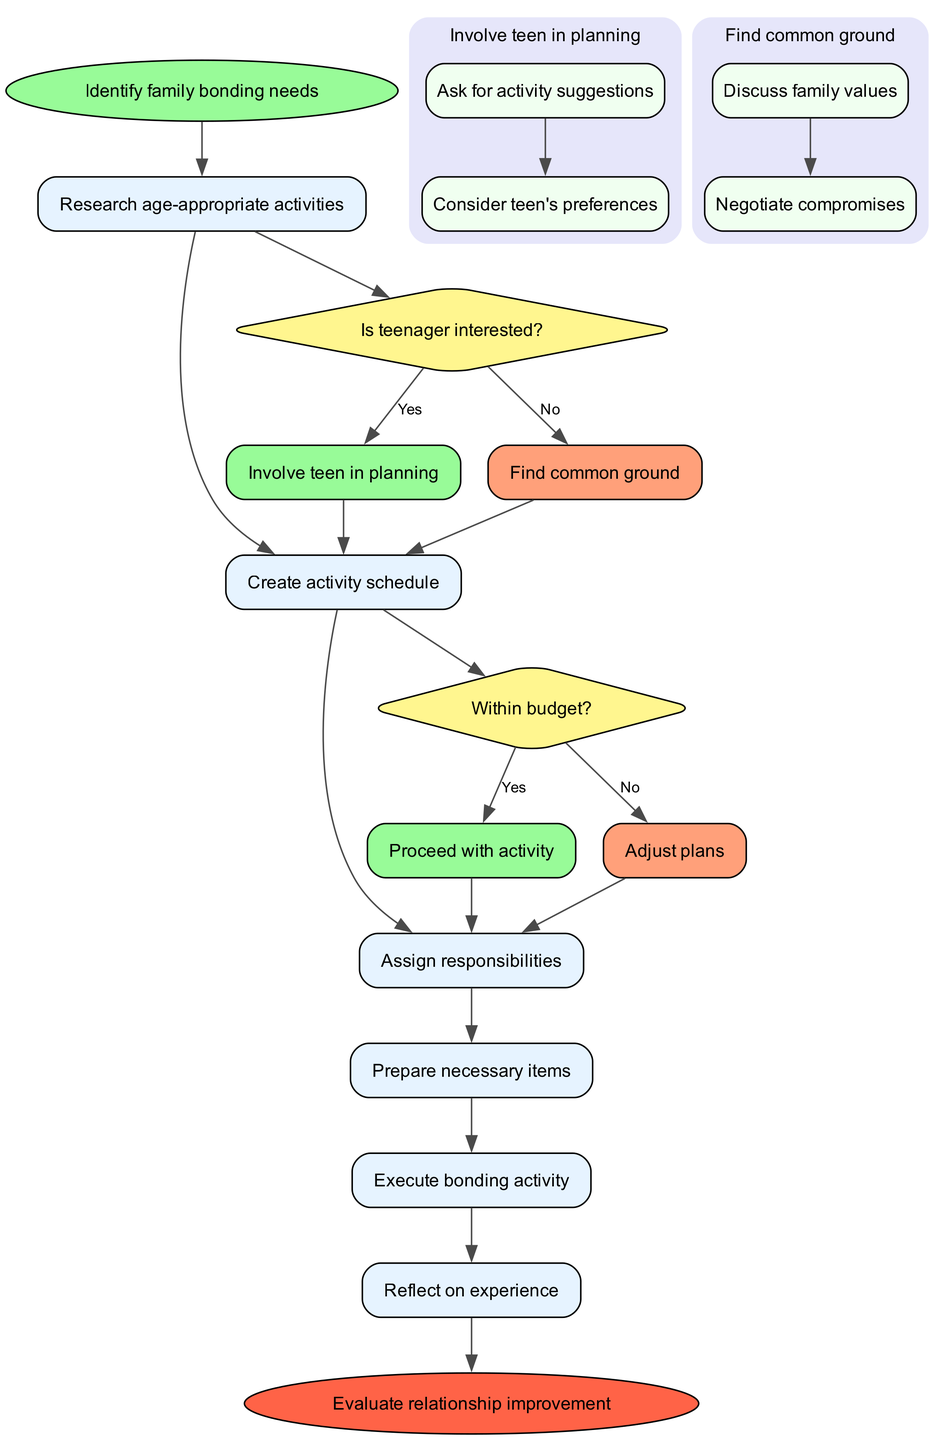What is the starting point of the workflow? The starting point is clearly labeled as "Identify family bonding needs," which is the first node in the diagram.
Answer: Identify family bonding needs How many decision points are in the diagram? There are two decision points: "Is teenager interested?" and "Within budget?" These can be counted based on the diamond-shaped nodes.
Answer: 2 What happens if the teenager is interested? If the teenager is interested, the workflow states "Involve teen in planning," which is the designated output from the condition check.
Answer: Involve teen in planning After "Research age-appropriate activities," which process comes next? The next process after "Research age-appropriate activities" is identified by following the arrows in the diagram, leading directly to "Create activity schedule."
Answer: Create activity schedule What follows if the budget is not met? If the budget is not met, the flow directs to the decision "Adjust plans," which is the output when the condition evaluates to no.
Answer: Adjust plans Which subprocesses are involved when the teenager is included in planning? The subprocesses under "Involve teen in planning" are "Ask for activity suggestions" and "Consider teen's preferences." This can be identified by looking into the associated subprocess nodes.
Answer: Ask for activity suggestions, Consider teen's preferences How does the flowchart end? The workflow concludes with the node labeled "Evaluate relationship improvement," distinctly marked as the final point in the diagram flow.
Answer: Evaluate relationship improvement What is the color of the decision nodes in the diagram? The decision nodes are filled with a light yellow color, specifically indicated in the node style attributes of the diagram.
Answer: Light yellow What is the process immediately following "Assign responsibilities"? Following "Assign responsibilities," the immediate process is "Prepare necessary items," which is seen by tracing the path in the diagram.
Answer: Prepare necessary items What would happen after reflecting on the experience? After "Reflect on experience," the workflow ends, leading to the conclusion node "Evaluate relationship improvement," signifying the closure of the bonding activity workflow.
Answer: Evaluate relationship improvement 